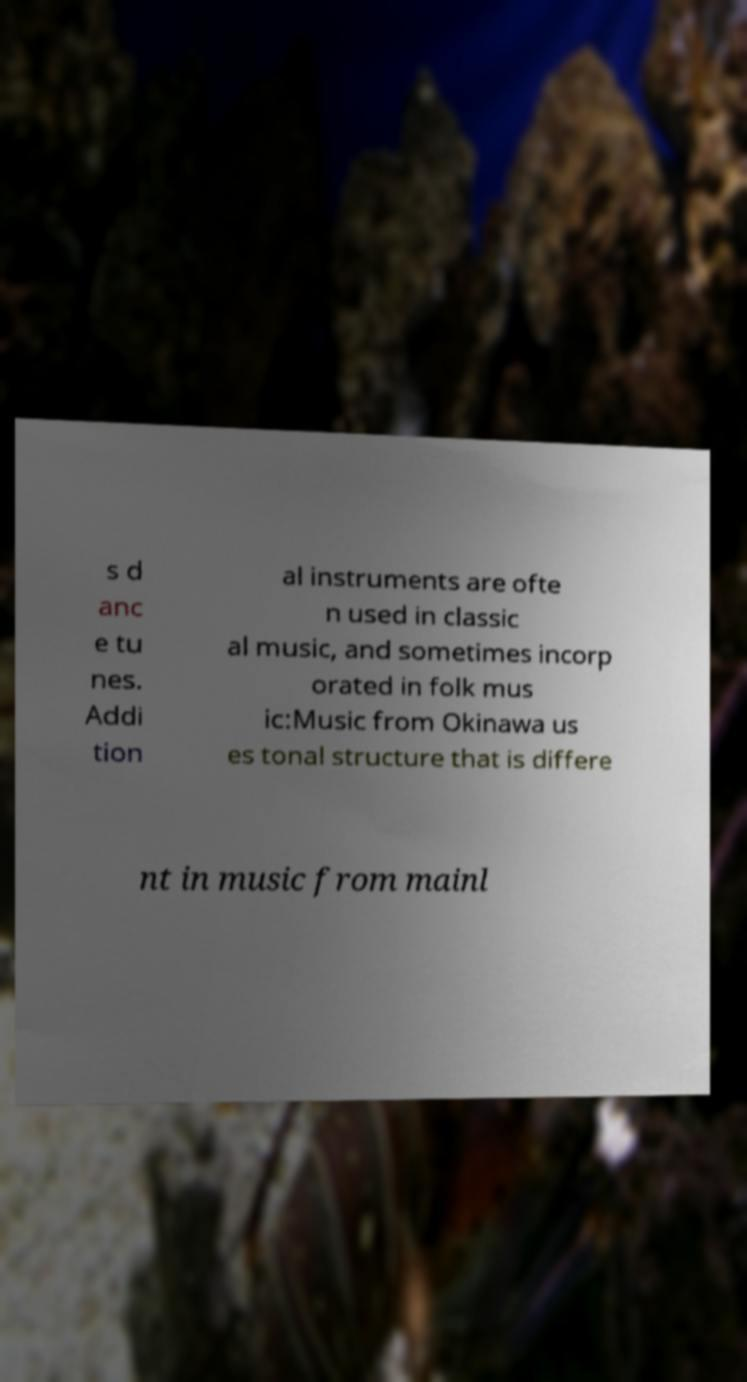Can you accurately transcribe the text from the provided image for me? s d anc e tu nes. Addi tion al instruments are ofte n used in classic al music, and sometimes incorp orated in folk mus ic:Music from Okinawa us es tonal structure that is differe nt in music from mainl 